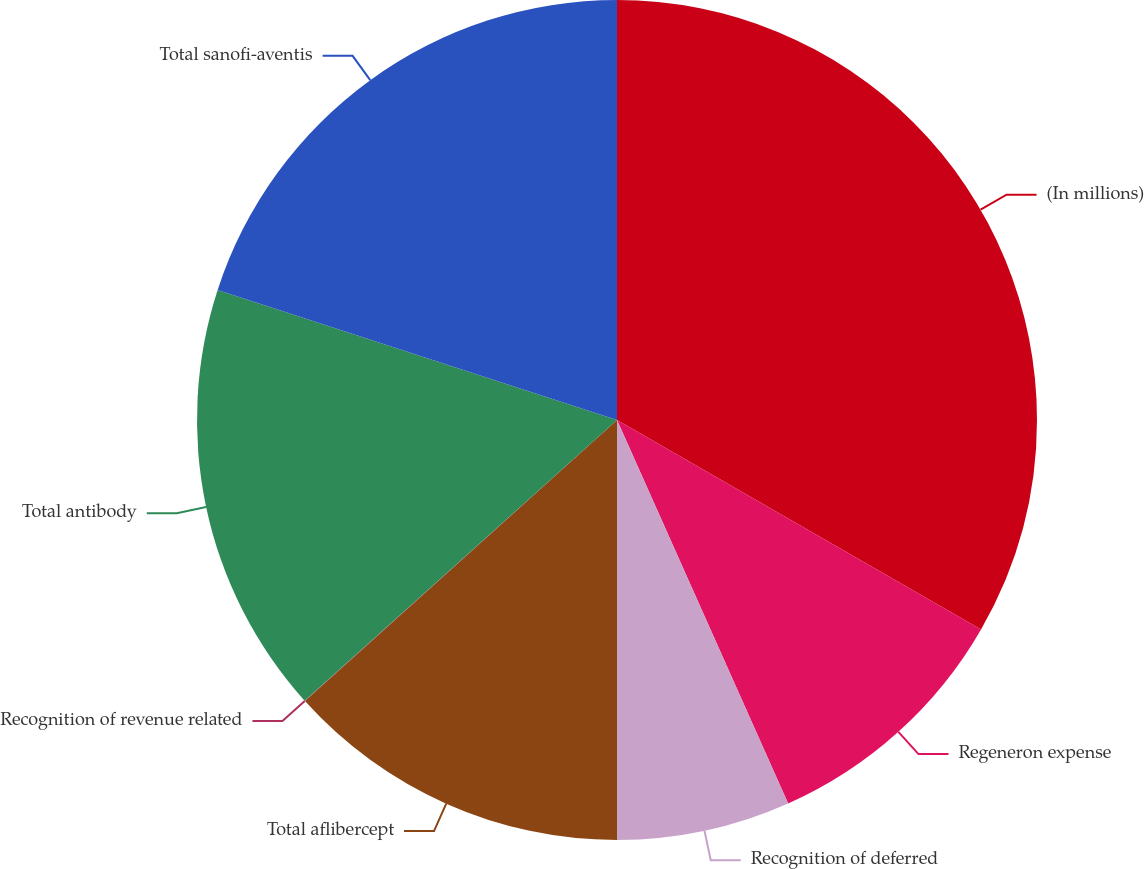<chart> <loc_0><loc_0><loc_500><loc_500><pie_chart><fcel>(In millions)<fcel>Regeneron expense<fcel>Recognition of deferred<fcel>Total aflibercept<fcel>Recognition of revenue related<fcel>Total antibody<fcel>Total sanofi-aventis<nl><fcel>33.31%<fcel>10.01%<fcel>6.68%<fcel>13.33%<fcel>0.02%<fcel>16.66%<fcel>19.99%<nl></chart> 